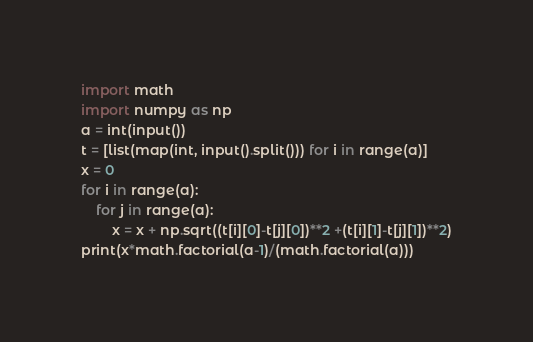Convert code to text. <code><loc_0><loc_0><loc_500><loc_500><_Python_>import math
import numpy as np
a = int(input())
t = [list(map(int, input().split())) for i in range(a)]
x = 0
for i in range(a):
    for j in range(a):
        x = x + np.sqrt((t[i][0]-t[j][0])**2 +(t[i][1]-t[j][1])**2)
print(x*math.factorial(a-1)/(math.factorial(a)))  </code> 